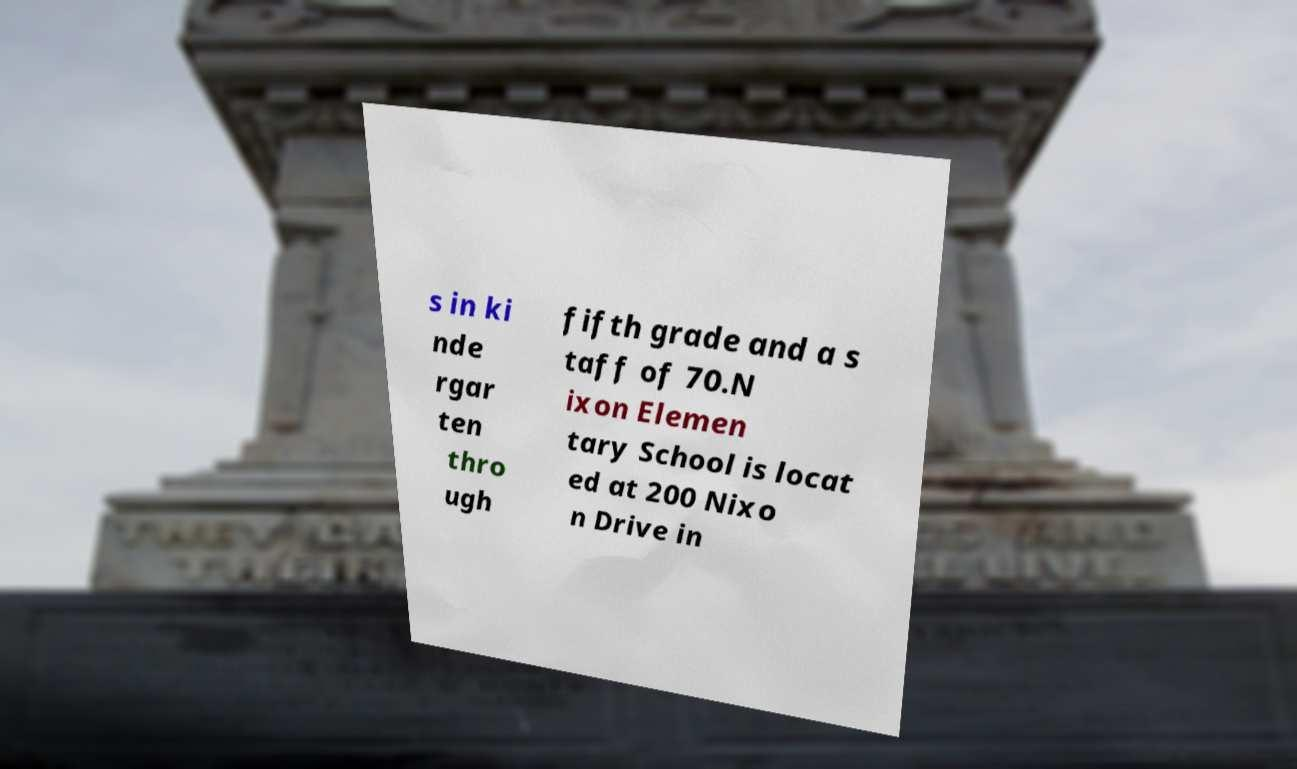What messages or text are displayed in this image? I need them in a readable, typed format. s in ki nde rgar ten thro ugh fifth grade and a s taff of 70.N ixon Elemen tary School is locat ed at 200 Nixo n Drive in 